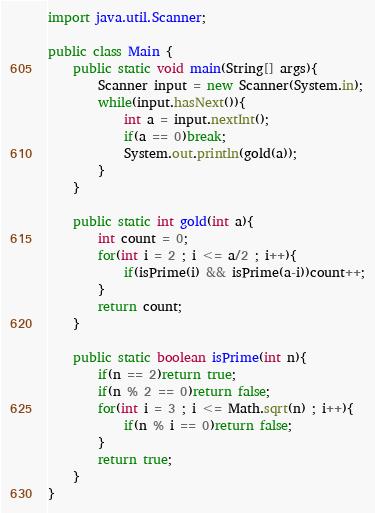Convert code to text. <code><loc_0><loc_0><loc_500><loc_500><_Java_>import java.util.Scanner;

public class Main {
    public static void main(String[] args){
    	Scanner input = new Scanner(System.in);
    	while(input.hasNext()){
    		int a = input.nextInt();
    		if(a == 0)break;
    		System.out.println(gold(a));
    	}
    }
    
    public static int gold(int a){
    	int count = 0;
    	for(int i = 2 ; i <= a/2 ; i++){
    		if(isPrime(i) && isPrime(a-i))count++;
    	}
    	return count;
    }
    
    public static boolean isPrime(int n){
    	if(n == 2)return true;
    	if(n % 2 == 0)return false;
    	for(int i = 3 ; i <= Math.sqrt(n) ; i++){
    		if(n % i == 0)return false;
    	}
    	return true;
    }
}</code> 